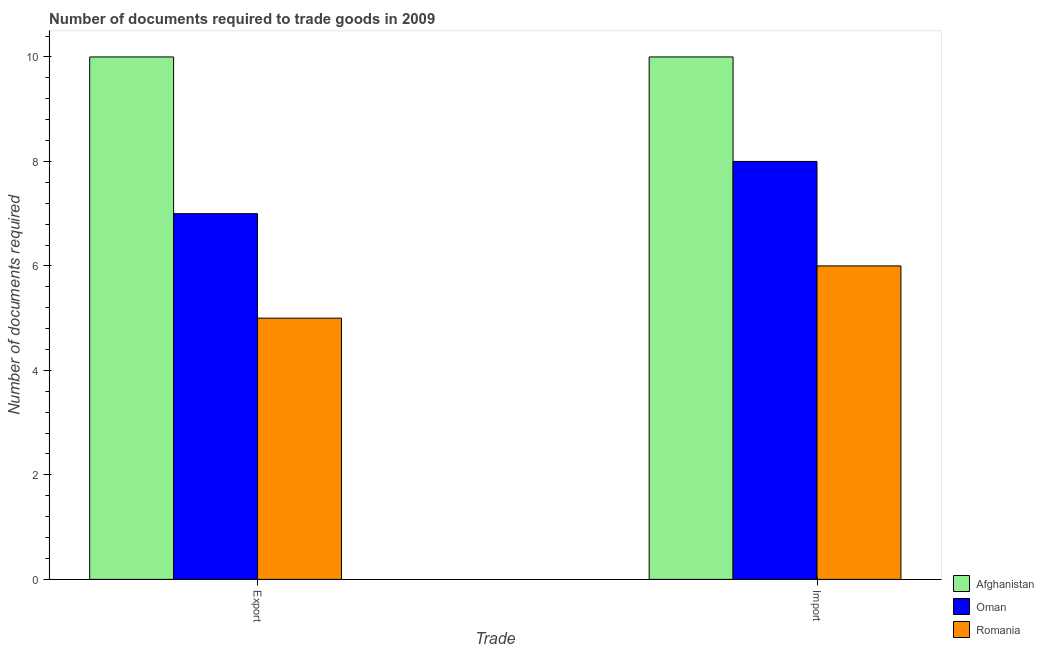Are the number of bars on each tick of the X-axis equal?
Your answer should be very brief. Yes. How many bars are there on the 1st tick from the right?
Your answer should be compact. 3. What is the label of the 2nd group of bars from the left?
Provide a succinct answer. Import. What is the number of documents required to export goods in Afghanistan?
Your answer should be very brief. 10. Across all countries, what is the maximum number of documents required to import goods?
Give a very brief answer. 10. In which country was the number of documents required to import goods maximum?
Your answer should be compact. Afghanistan. In which country was the number of documents required to export goods minimum?
Make the answer very short. Romania. What is the total number of documents required to export goods in the graph?
Provide a short and direct response. 22. What is the difference between the number of documents required to import goods in Romania and that in Oman?
Offer a very short reply. -2. What is the difference between the number of documents required to import goods in Oman and the number of documents required to export goods in Romania?
Keep it short and to the point. 3. What is the difference between the number of documents required to export goods and number of documents required to import goods in Romania?
Keep it short and to the point. -1. What is the ratio of the number of documents required to import goods in Oman to that in Romania?
Offer a terse response. 1.33. Is the number of documents required to import goods in Oman less than that in Romania?
Your response must be concise. No. What does the 2nd bar from the left in Import represents?
Provide a succinct answer. Oman. What does the 1st bar from the right in Import represents?
Give a very brief answer. Romania. How many bars are there?
Provide a short and direct response. 6. How many countries are there in the graph?
Make the answer very short. 3. What is the difference between two consecutive major ticks on the Y-axis?
Make the answer very short. 2. Are the values on the major ticks of Y-axis written in scientific E-notation?
Your answer should be compact. No. Where does the legend appear in the graph?
Ensure brevity in your answer.  Bottom right. What is the title of the graph?
Offer a very short reply. Number of documents required to trade goods in 2009. What is the label or title of the X-axis?
Offer a terse response. Trade. What is the label or title of the Y-axis?
Ensure brevity in your answer.  Number of documents required. What is the Number of documents required in Afghanistan in Export?
Ensure brevity in your answer.  10. What is the Number of documents required in Afghanistan in Import?
Offer a very short reply. 10. What is the Number of documents required of Oman in Import?
Your response must be concise. 8. Across all Trade, what is the maximum Number of documents required of Afghanistan?
Your response must be concise. 10. Across all Trade, what is the maximum Number of documents required in Oman?
Ensure brevity in your answer.  8. Across all Trade, what is the minimum Number of documents required of Afghanistan?
Make the answer very short. 10. Across all Trade, what is the minimum Number of documents required in Romania?
Offer a very short reply. 5. What is the total Number of documents required of Afghanistan in the graph?
Your answer should be compact. 20. What is the total Number of documents required of Romania in the graph?
Provide a short and direct response. 11. What is the difference between the Number of documents required in Oman in Export and that in Import?
Make the answer very short. -1. What is the difference between the Number of documents required of Afghanistan in Export and the Number of documents required of Oman in Import?
Your response must be concise. 2. What is the difference between the Number of documents required in Afghanistan in Export and the Number of documents required in Romania in Import?
Keep it short and to the point. 4. What is the average Number of documents required in Oman per Trade?
Give a very brief answer. 7.5. What is the difference between the Number of documents required in Oman and Number of documents required in Romania in Export?
Provide a succinct answer. 2. What is the difference between the Number of documents required in Afghanistan and Number of documents required in Romania in Import?
Provide a succinct answer. 4. What is the difference between the Number of documents required in Oman and Number of documents required in Romania in Import?
Offer a terse response. 2. What is the ratio of the Number of documents required of Afghanistan in Export to that in Import?
Offer a terse response. 1. What is the ratio of the Number of documents required in Romania in Export to that in Import?
Your response must be concise. 0.83. What is the difference between the highest and the second highest Number of documents required of Oman?
Provide a succinct answer. 1. What is the difference between the highest and the second highest Number of documents required in Romania?
Give a very brief answer. 1. What is the difference between the highest and the lowest Number of documents required of Afghanistan?
Your answer should be very brief. 0. What is the difference between the highest and the lowest Number of documents required of Romania?
Keep it short and to the point. 1. 